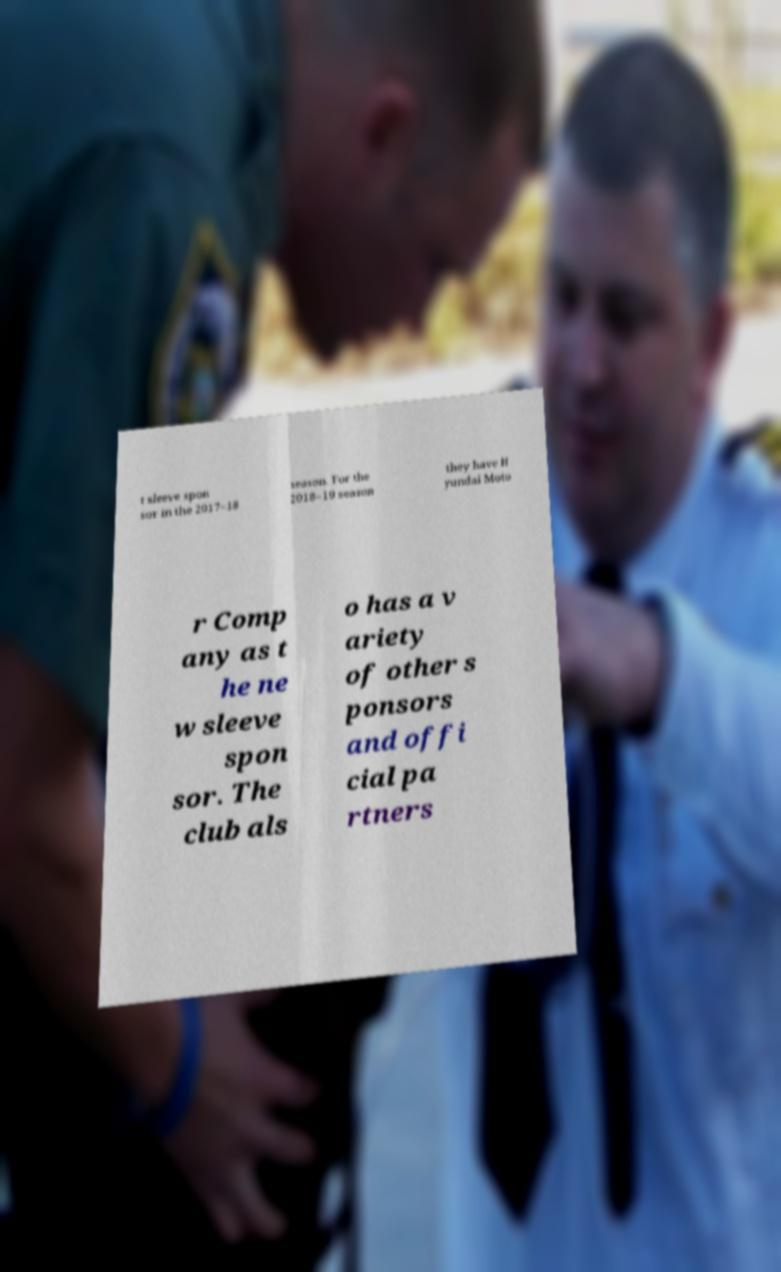What messages or text are displayed in this image? I need them in a readable, typed format. t sleeve spon sor in the 2017–18 season. For the 2018–19 season they have H yundai Moto r Comp any as t he ne w sleeve spon sor. The club als o has a v ariety of other s ponsors and offi cial pa rtners 